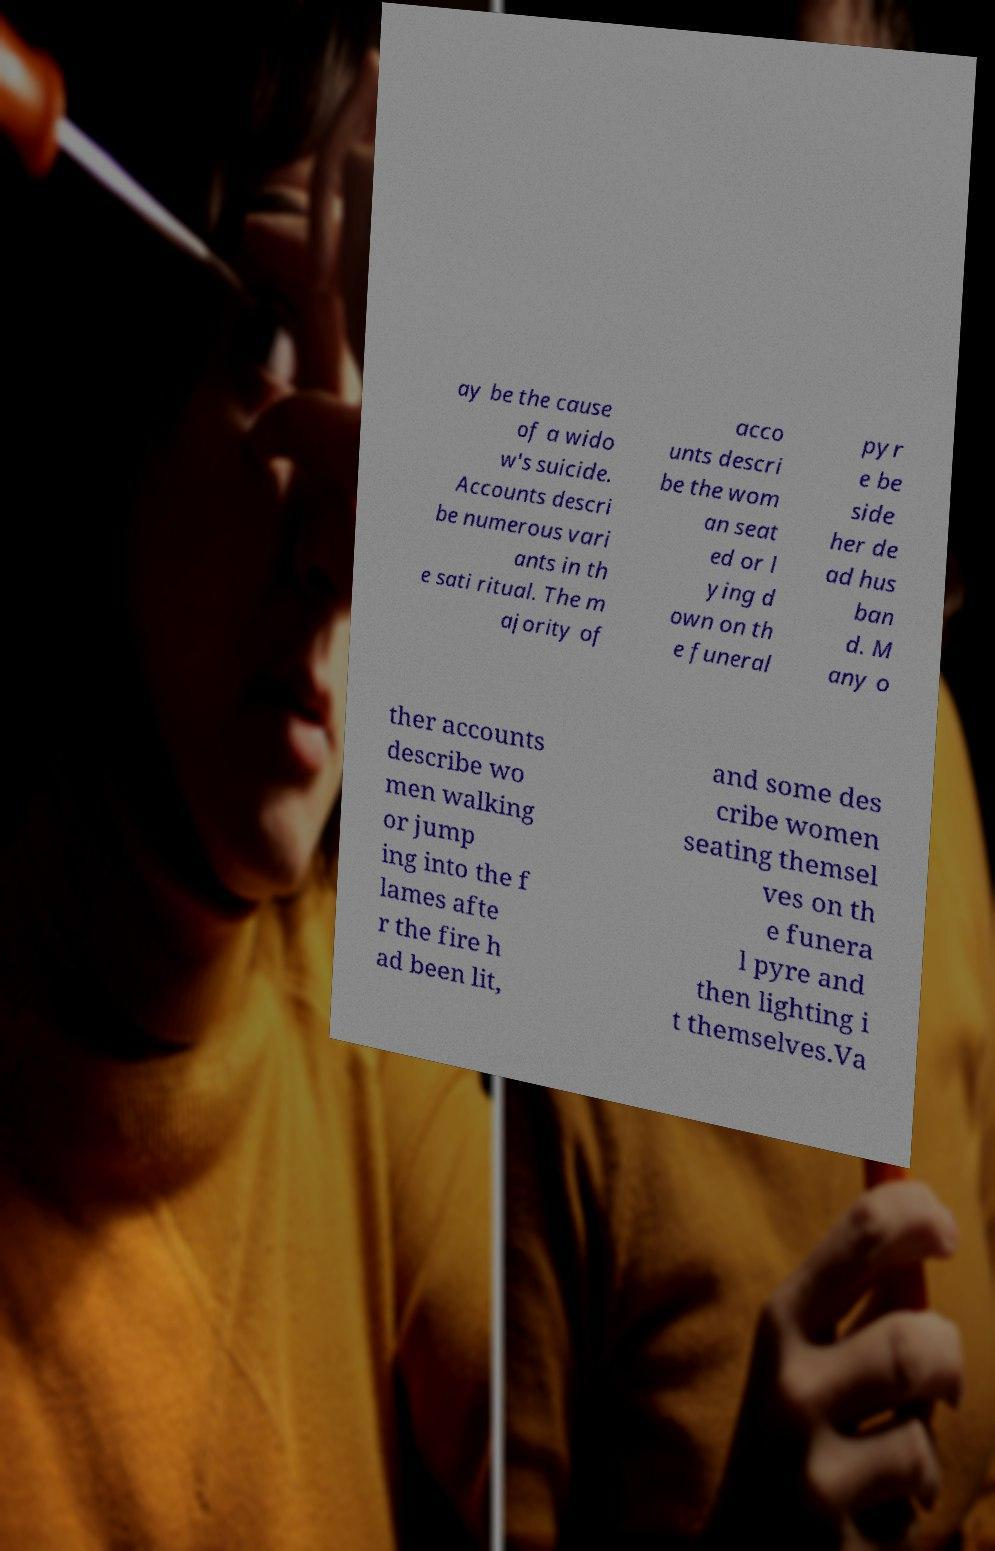Could you assist in decoding the text presented in this image and type it out clearly? ay be the cause of a wido w's suicide. Accounts descri be numerous vari ants in th e sati ritual. The m ajority of acco unts descri be the wom an seat ed or l ying d own on th e funeral pyr e be side her de ad hus ban d. M any o ther accounts describe wo men walking or jump ing into the f lames afte r the fire h ad been lit, and some des cribe women seating themsel ves on th e funera l pyre and then lighting i t themselves.Va 